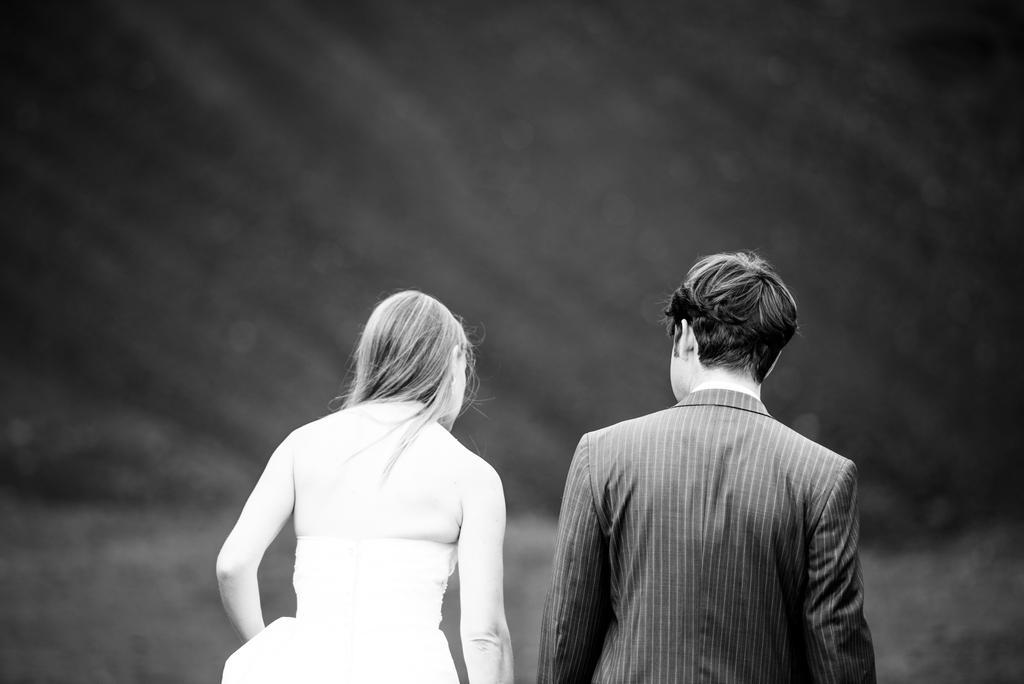Can you describe this image briefly? This is a black and white image of a couple. 